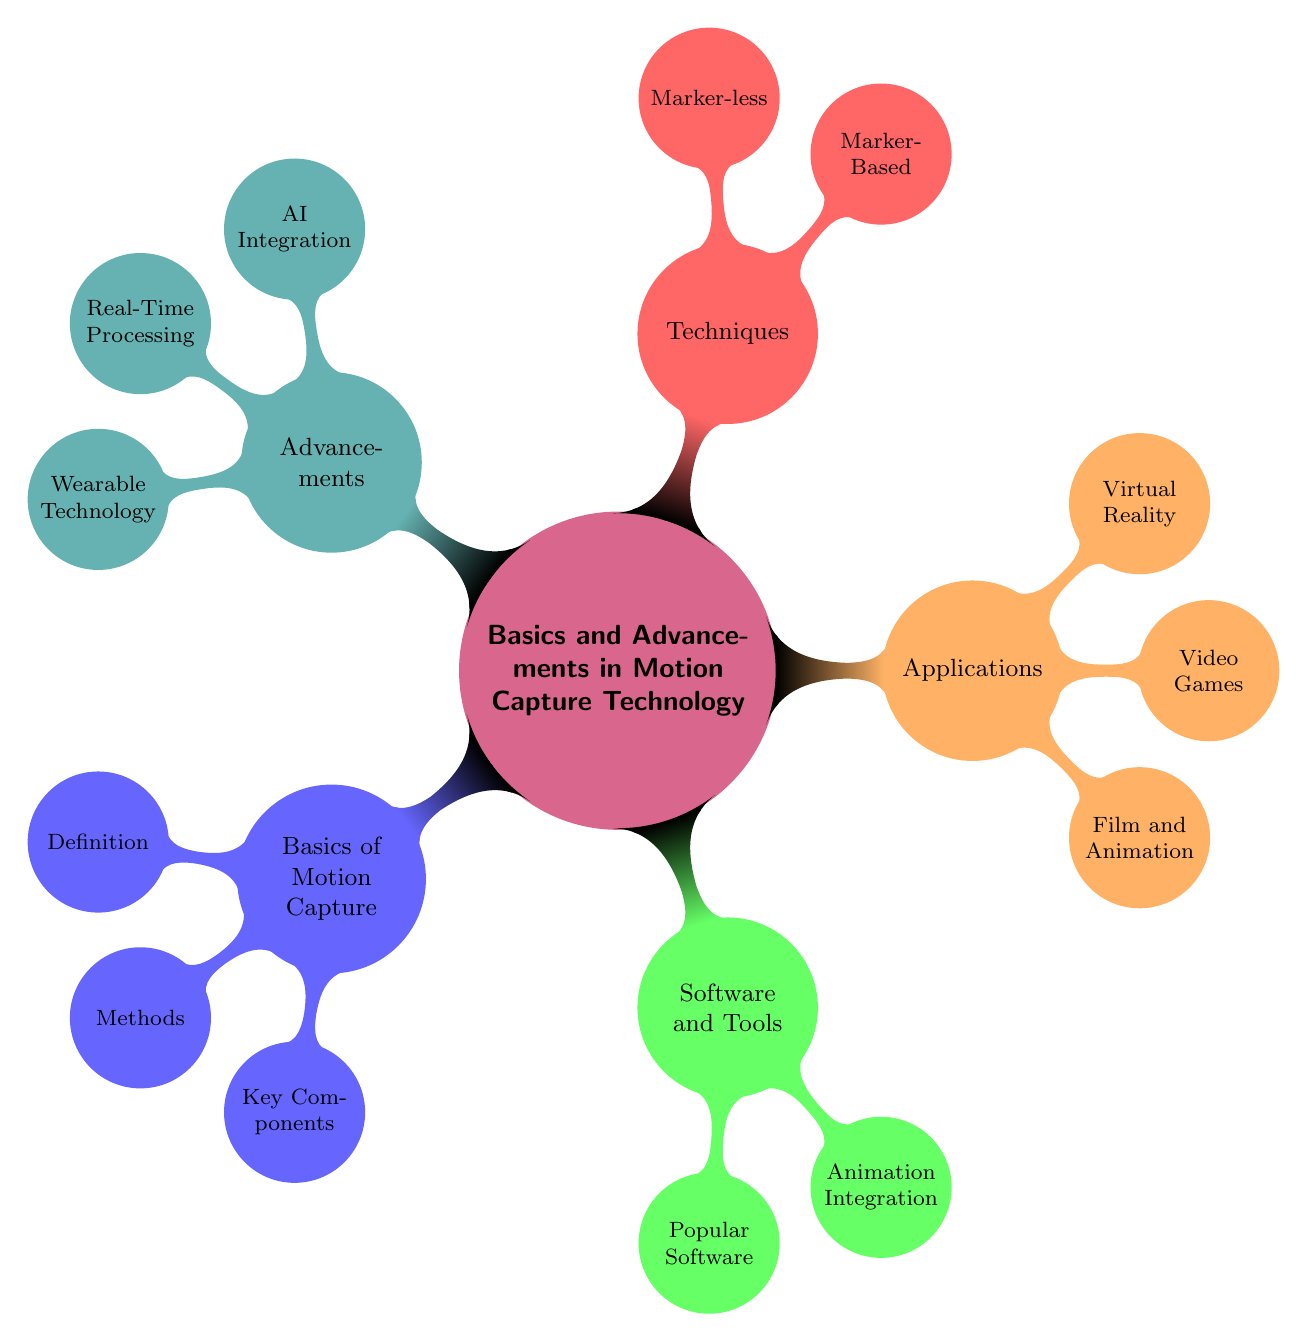What is the main topic of the mind map? The main topic is provided at the center of the mind map. It is the primary focus of all the surrounding nodes.
Answer: Basics and Advancements in Motion Capture Technology How many subnodes does the "Applications" node have? The "Applications" node directly connects to three subnodes. Counting them gives the total number of subnodes.
Answer: 3 What are the two main types of techniques mentioned? The "Techniques" node lists two specific types that are categorized under it. These can be found as immediate subnodes of "Techniques."
Answer: Marker-Based and Marker-less Which category includes the "Vicon" software? The "Vicon" software is mentioned as part of the subnodes under "Software and Tools," indicating its association with this category.
Answer: Software and Tools What advancement includes "machine learning"? The subnode under "Advancements" discusses the integration of AI to improve motion capture accuracy, specifying the role of machine learning in this context.
Answer: AI Integration In how many categories is motion capture applied? The mind map clearly states three distinct categories where motion capture is applied, found in the "Applications" node.
Answer: 3 Which component is essential for optical motion capture systems? "Cameras" are explicitly listed as a key component under the "Key Components" subnode, essential for optical systems.
Answer: Cameras Describe one method of motion capture listed in the mind map. The "Methods" subnode outlines two methods, giving one explicit example which describes the use of reflective markers for motion capture.
Answer: Optical Systems What is the relationship between "Animation Integration" and "Popular Software"? "Animation Integration" is a detail found under "Software and Tools," showing its reliance on various software tools to blend motion capture data with animation.
Answer: They are both subnodes of Software and Tools 